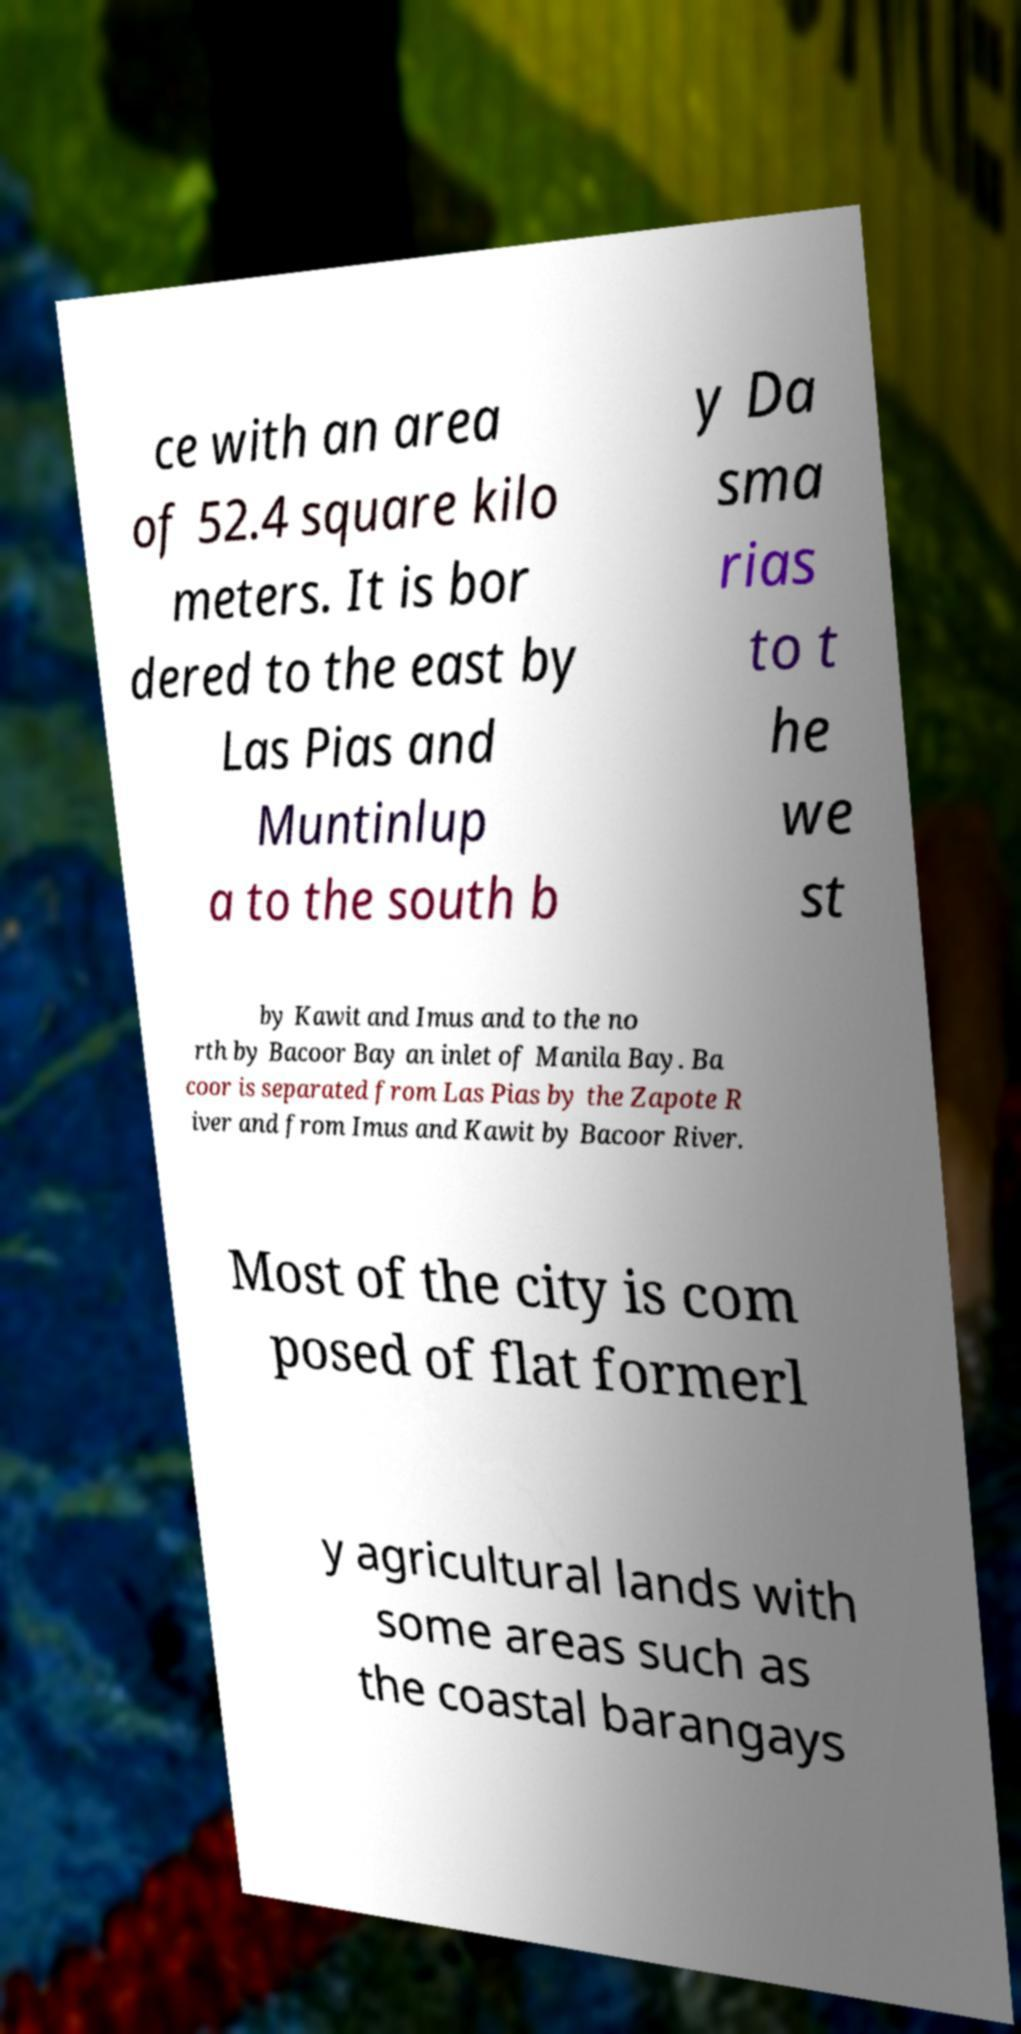I need the written content from this picture converted into text. Can you do that? ce with an area of 52.4 square kilo meters. It is bor dered to the east by Las Pias and Muntinlup a to the south b y Da sma rias to t he we st by Kawit and Imus and to the no rth by Bacoor Bay an inlet of Manila Bay. Ba coor is separated from Las Pias by the Zapote R iver and from Imus and Kawit by Bacoor River. Most of the city is com posed of flat formerl y agricultural lands with some areas such as the coastal barangays 